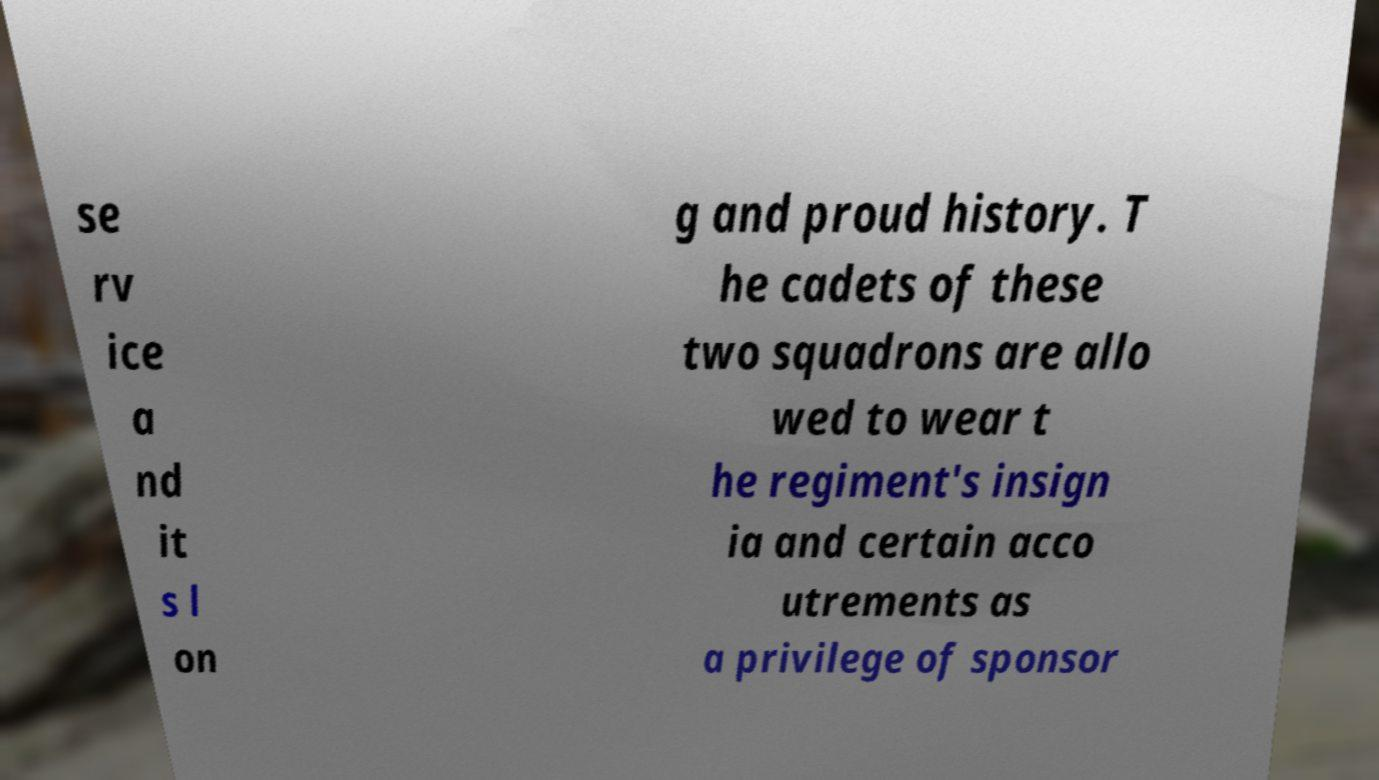What messages or text are displayed in this image? I need them in a readable, typed format. se rv ice a nd it s l on g and proud history. T he cadets of these two squadrons are allo wed to wear t he regiment's insign ia and certain acco utrements as a privilege of sponsor 